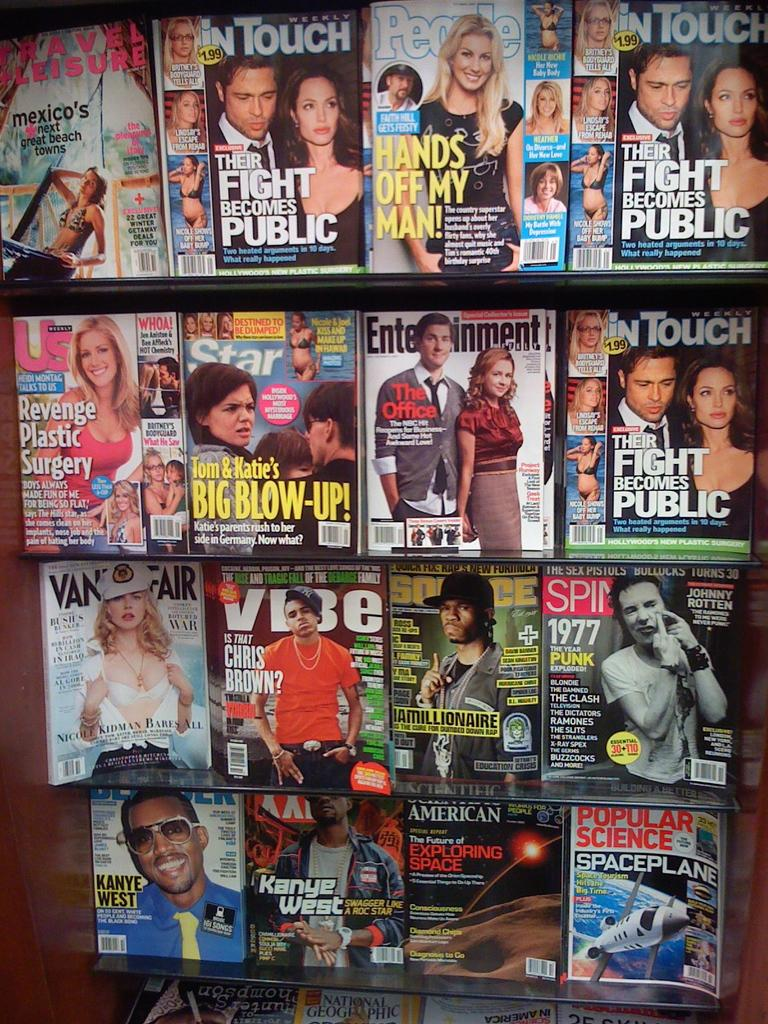What can be seen in the image that is used for storage? There are racks in the image that are used for storage. What items are stored on the racks? There are books on the racks. What can be observed on the books? The books have images and text written on them. Can you tell me how many goldfish are swimming in the books in the image? There are no goldfish present in the image; the image features books with images and text on them. What type of card is being used to hold the books together in the image? There is no card visible in the image; the books are stored on racks. 